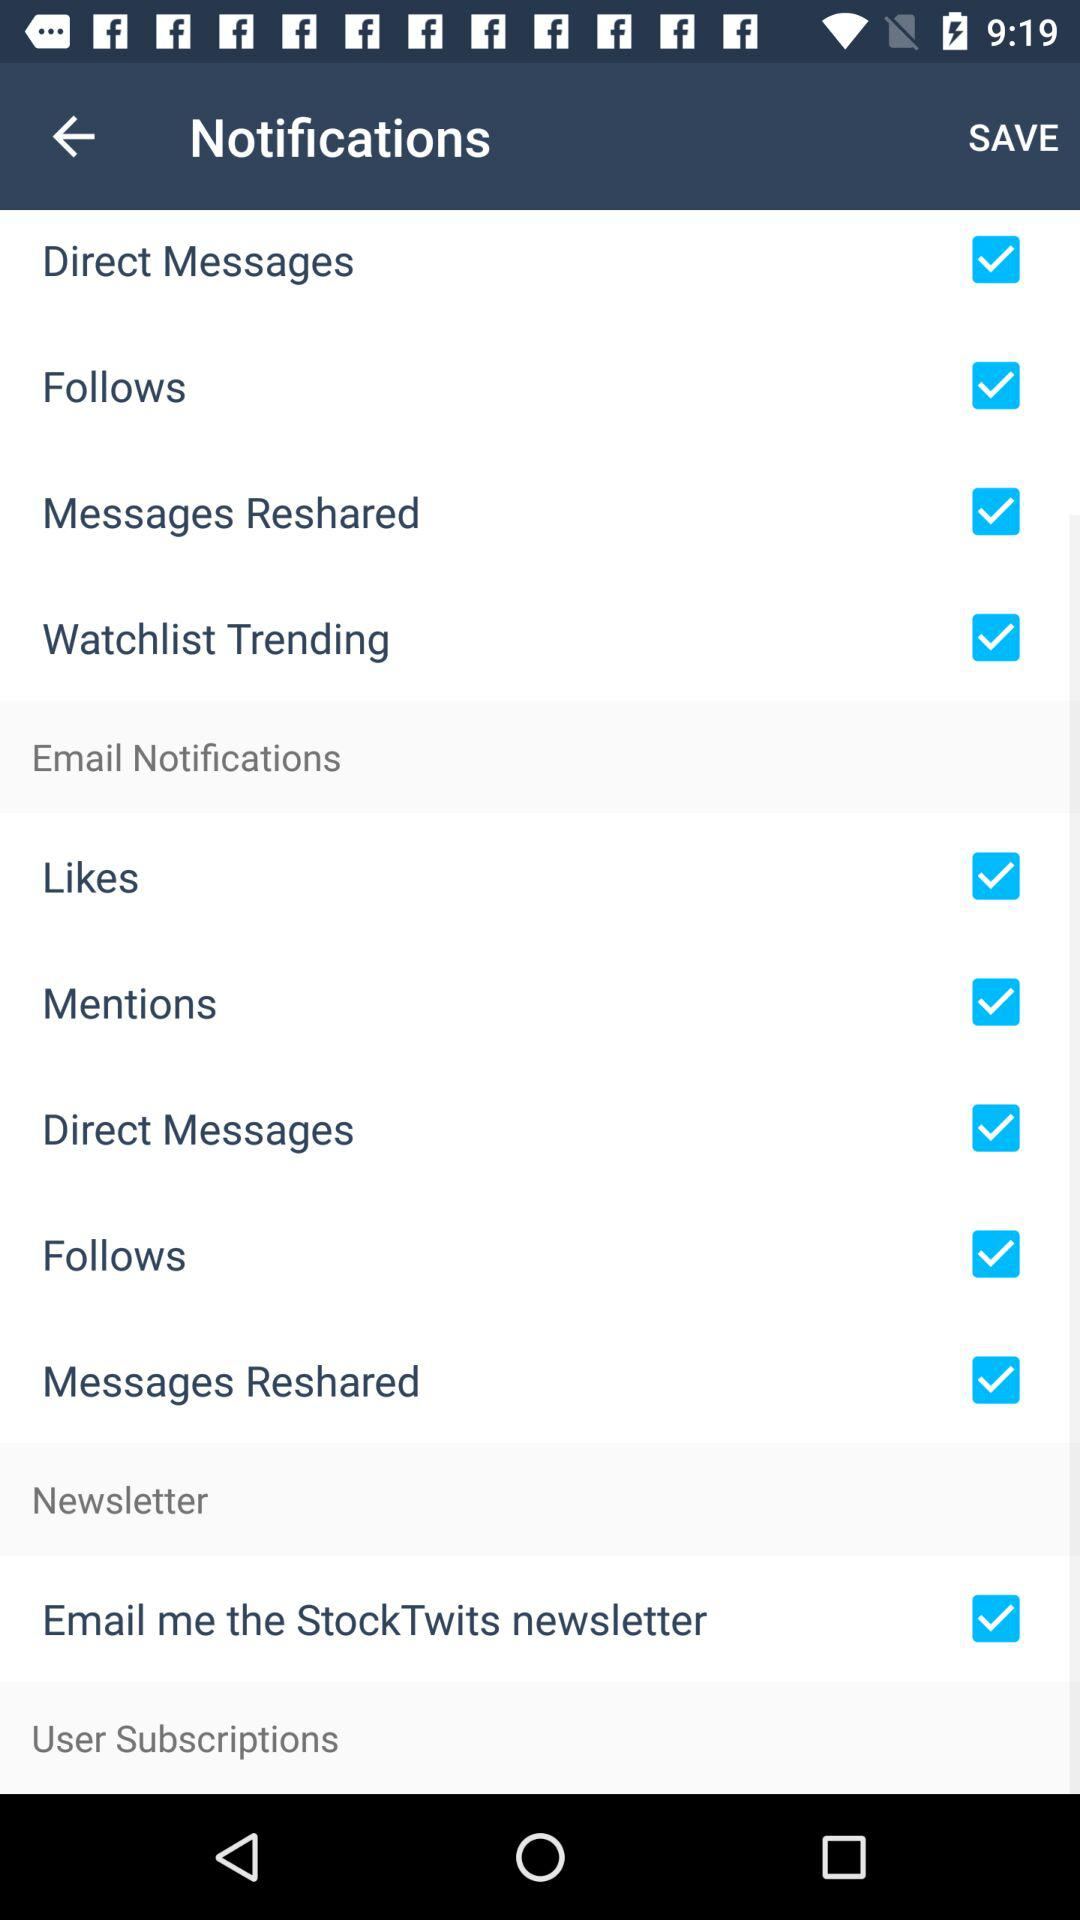Is "Email Notifications" checked or unchecked?
When the provided information is insufficient, respond with <no answer>. <no answer> 